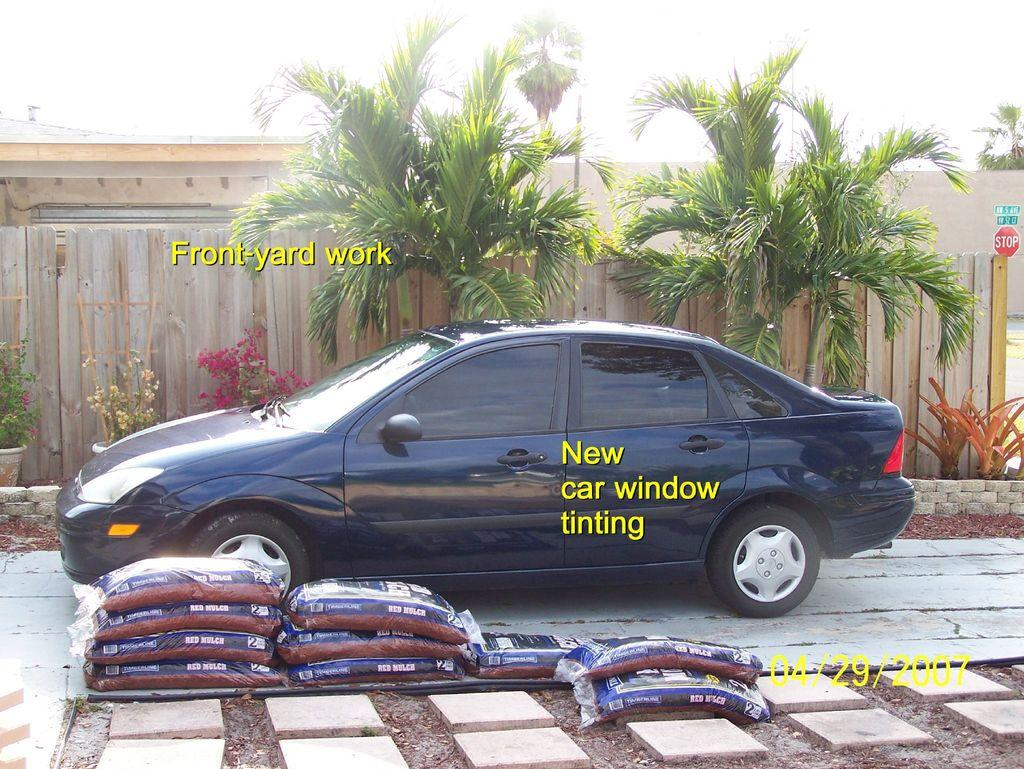<image>
Give a short and clear explanation of the subsequent image. An advertisement for Front Yard Work of a car parked in a driveway/ 